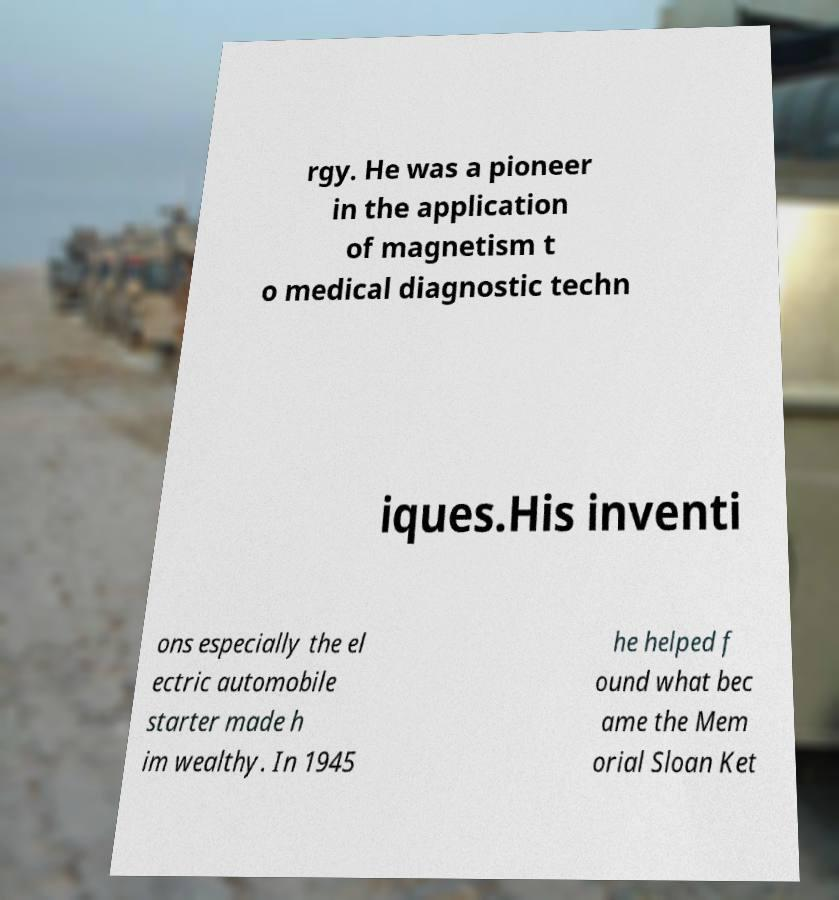There's text embedded in this image that I need extracted. Can you transcribe it verbatim? rgy. He was a pioneer in the application of magnetism t o medical diagnostic techn iques.His inventi ons especially the el ectric automobile starter made h im wealthy. In 1945 he helped f ound what bec ame the Mem orial Sloan Ket 